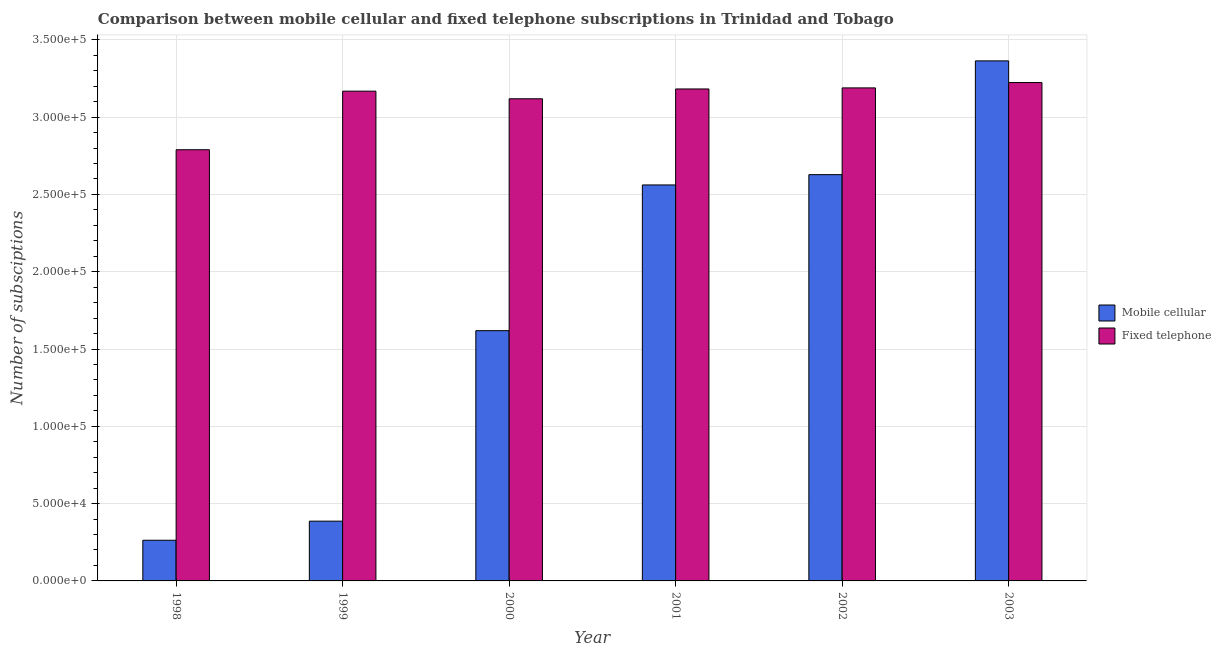How many different coloured bars are there?
Provide a short and direct response. 2. Are the number of bars per tick equal to the number of legend labels?
Offer a terse response. Yes. Are the number of bars on each tick of the X-axis equal?
Keep it short and to the point. Yes. What is the number of fixed telephone subscriptions in 2003?
Ensure brevity in your answer.  3.22e+05. Across all years, what is the maximum number of mobile cellular subscriptions?
Keep it short and to the point. 3.36e+05. Across all years, what is the minimum number of mobile cellular subscriptions?
Your answer should be very brief. 2.63e+04. What is the total number of fixed telephone subscriptions in the graph?
Your response must be concise. 1.87e+06. What is the difference between the number of mobile cellular subscriptions in 2000 and that in 2001?
Offer a terse response. -9.42e+04. What is the difference between the number of fixed telephone subscriptions in 2003 and the number of mobile cellular subscriptions in 1998?
Give a very brief answer. 4.35e+04. What is the average number of mobile cellular subscriptions per year?
Your answer should be compact. 1.80e+05. In the year 2003, what is the difference between the number of fixed telephone subscriptions and number of mobile cellular subscriptions?
Give a very brief answer. 0. What is the ratio of the number of fixed telephone subscriptions in 1999 to that in 2000?
Ensure brevity in your answer.  1.02. Is the number of mobile cellular subscriptions in 1999 less than that in 2002?
Give a very brief answer. Yes. What is the difference between the highest and the second highest number of fixed telephone subscriptions?
Keep it short and to the point. 3459. What is the difference between the highest and the lowest number of fixed telephone subscriptions?
Make the answer very short. 4.35e+04. In how many years, is the number of fixed telephone subscriptions greater than the average number of fixed telephone subscriptions taken over all years?
Provide a short and direct response. 5. What does the 2nd bar from the left in 1998 represents?
Keep it short and to the point. Fixed telephone. What does the 1st bar from the right in 1999 represents?
Provide a short and direct response. Fixed telephone. How many bars are there?
Your answer should be compact. 12. What is the difference between two consecutive major ticks on the Y-axis?
Your answer should be compact. 5.00e+04. Are the values on the major ticks of Y-axis written in scientific E-notation?
Provide a succinct answer. Yes. How many legend labels are there?
Keep it short and to the point. 2. How are the legend labels stacked?
Your answer should be compact. Vertical. What is the title of the graph?
Provide a succinct answer. Comparison between mobile cellular and fixed telephone subscriptions in Trinidad and Tobago. Does "Number of arrivals" appear as one of the legend labels in the graph?
Your answer should be compact. No. What is the label or title of the X-axis?
Offer a terse response. Year. What is the label or title of the Y-axis?
Your answer should be compact. Number of subsciptions. What is the Number of subsciptions of Mobile cellular in 1998?
Make the answer very short. 2.63e+04. What is the Number of subsciptions in Fixed telephone in 1998?
Offer a very short reply. 2.79e+05. What is the Number of subsciptions of Mobile cellular in 1999?
Your answer should be very brief. 3.87e+04. What is the Number of subsciptions in Fixed telephone in 1999?
Your answer should be compact. 3.17e+05. What is the Number of subsciptions in Mobile cellular in 2000?
Offer a terse response. 1.62e+05. What is the Number of subsciptions in Fixed telephone in 2000?
Keep it short and to the point. 3.12e+05. What is the Number of subsciptions in Mobile cellular in 2001?
Keep it short and to the point. 2.56e+05. What is the Number of subsciptions in Fixed telephone in 2001?
Provide a succinct answer. 3.18e+05. What is the Number of subsciptions in Mobile cellular in 2002?
Ensure brevity in your answer.  2.63e+05. What is the Number of subsciptions of Fixed telephone in 2002?
Give a very brief answer. 3.19e+05. What is the Number of subsciptions of Mobile cellular in 2003?
Your response must be concise. 3.36e+05. What is the Number of subsciptions of Fixed telephone in 2003?
Ensure brevity in your answer.  3.22e+05. Across all years, what is the maximum Number of subsciptions in Mobile cellular?
Make the answer very short. 3.36e+05. Across all years, what is the maximum Number of subsciptions of Fixed telephone?
Provide a short and direct response. 3.22e+05. Across all years, what is the minimum Number of subsciptions of Mobile cellular?
Your answer should be compact. 2.63e+04. Across all years, what is the minimum Number of subsciptions of Fixed telephone?
Provide a short and direct response. 2.79e+05. What is the total Number of subsciptions in Mobile cellular in the graph?
Give a very brief answer. 1.08e+06. What is the total Number of subsciptions of Fixed telephone in the graph?
Provide a short and direct response. 1.87e+06. What is the difference between the Number of subsciptions of Mobile cellular in 1998 and that in 1999?
Make the answer very short. -1.24e+04. What is the difference between the Number of subsciptions of Fixed telephone in 1998 and that in 1999?
Your response must be concise. -3.79e+04. What is the difference between the Number of subsciptions in Mobile cellular in 1998 and that in 2000?
Your answer should be very brief. -1.36e+05. What is the difference between the Number of subsciptions of Fixed telephone in 1998 and that in 2000?
Keep it short and to the point. -3.30e+04. What is the difference between the Number of subsciptions of Mobile cellular in 1998 and that in 2001?
Offer a very short reply. -2.30e+05. What is the difference between the Number of subsciptions of Fixed telephone in 1998 and that in 2001?
Offer a terse response. -3.93e+04. What is the difference between the Number of subsciptions in Mobile cellular in 1998 and that in 2002?
Offer a very short reply. -2.36e+05. What is the difference between the Number of subsciptions of Fixed telephone in 1998 and that in 2002?
Provide a short and direct response. -4.00e+04. What is the difference between the Number of subsciptions in Mobile cellular in 1998 and that in 2003?
Ensure brevity in your answer.  -3.10e+05. What is the difference between the Number of subsciptions in Fixed telephone in 1998 and that in 2003?
Ensure brevity in your answer.  -4.35e+04. What is the difference between the Number of subsciptions in Mobile cellular in 1999 and that in 2000?
Give a very brief answer. -1.23e+05. What is the difference between the Number of subsciptions in Fixed telephone in 1999 and that in 2000?
Ensure brevity in your answer.  4925. What is the difference between the Number of subsciptions in Mobile cellular in 1999 and that in 2001?
Give a very brief answer. -2.17e+05. What is the difference between the Number of subsciptions of Fixed telephone in 1999 and that in 2001?
Your answer should be compact. -1422. What is the difference between the Number of subsciptions in Mobile cellular in 1999 and that in 2002?
Ensure brevity in your answer.  -2.24e+05. What is the difference between the Number of subsciptions of Fixed telephone in 1999 and that in 2002?
Provide a succinct answer. -2112. What is the difference between the Number of subsciptions in Mobile cellular in 1999 and that in 2003?
Your answer should be compact. -2.98e+05. What is the difference between the Number of subsciptions of Fixed telephone in 1999 and that in 2003?
Give a very brief answer. -5571. What is the difference between the Number of subsciptions of Mobile cellular in 2000 and that in 2001?
Keep it short and to the point. -9.42e+04. What is the difference between the Number of subsciptions in Fixed telephone in 2000 and that in 2001?
Your answer should be very brief. -6347. What is the difference between the Number of subsciptions in Mobile cellular in 2000 and that in 2002?
Your response must be concise. -1.01e+05. What is the difference between the Number of subsciptions in Fixed telephone in 2000 and that in 2002?
Provide a succinct answer. -7037. What is the difference between the Number of subsciptions in Mobile cellular in 2000 and that in 2003?
Give a very brief answer. -1.74e+05. What is the difference between the Number of subsciptions in Fixed telephone in 2000 and that in 2003?
Make the answer very short. -1.05e+04. What is the difference between the Number of subsciptions in Mobile cellular in 2001 and that in 2002?
Ensure brevity in your answer.  -6666. What is the difference between the Number of subsciptions in Fixed telephone in 2001 and that in 2002?
Provide a succinct answer. -690. What is the difference between the Number of subsciptions in Mobile cellular in 2001 and that in 2003?
Keep it short and to the point. -8.02e+04. What is the difference between the Number of subsciptions in Fixed telephone in 2001 and that in 2003?
Your answer should be very brief. -4149. What is the difference between the Number of subsciptions of Mobile cellular in 2002 and that in 2003?
Offer a terse response. -7.36e+04. What is the difference between the Number of subsciptions of Fixed telephone in 2002 and that in 2003?
Your response must be concise. -3459. What is the difference between the Number of subsciptions in Mobile cellular in 1998 and the Number of subsciptions in Fixed telephone in 1999?
Provide a succinct answer. -2.90e+05. What is the difference between the Number of subsciptions in Mobile cellular in 1998 and the Number of subsciptions in Fixed telephone in 2000?
Your answer should be compact. -2.86e+05. What is the difference between the Number of subsciptions in Mobile cellular in 1998 and the Number of subsciptions in Fixed telephone in 2001?
Offer a very short reply. -2.92e+05. What is the difference between the Number of subsciptions in Mobile cellular in 1998 and the Number of subsciptions in Fixed telephone in 2002?
Ensure brevity in your answer.  -2.93e+05. What is the difference between the Number of subsciptions of Mobile cellular in 1998 and the Number of subsciptions of Fixed telephone in 2003?
Provide a succinct answer. -2.96e+05. What is the difference between the Number of subsciptions of Mobile cellular in 1999 and the Number of subsciptions of Fixed telephone in 2000?
Provide a succinct answer. -2.73e+05. What is the difference between the Number of subsciptions in Mobile cellular in 1999 and the Number of subsciptions in Fixed telephone in 2001?
Give a very brief answer. -2.80e+05. What is the difference between the Number of subsciptions in Mobile cellular in 1999 and the Number of subsciptions in Fixed telephone in 2002?
Keep it short and to the point. -2.80e+05. What is the difference between the Number of subsciptions of Mobile cellular in 1999 and the Number of subsciptions of Fixed telephone in 2003?
Provide a short and direct response. -2.84e+05. What is the difference between the Number of subsciptions of Mobile cellular in 2000 and the Number of subsciptions of Fixed telephone in 2001?
Your answer should be compact. -1.56e+05. What is the difference between the Number of subsciptions in Mobile cellular in 2000 and the Number of subsciptions in Fixed telephone in 2002?
Offer a very short reply. -1.57e+05. What is the difference between the Number of subsciptions of Mobile cellular in 2000 and the Number of subsciptions of Fixed telephone in 2003?
Your response must be concise. -1.60e+05. What is the difference between the Number of subsciptions of Mobile cellular in 2001 and the Number of subsciptions of Fixed telephone in 2002?
Provide a short and direct response. -6.28e+04. What is the difference between the Number of subsciptions in Mobile cellular in 2001 and the Number of subsciptions in Fixed telephone in 2003?
Provide a short and direct response. -6.62e+04. What is the difference between the Number of subsciptions in Mobile cellular in 2002 and the Number of subsciptions in Fixed telephone in 2003?
Ensure brevity in your answer.  -5.96e+04. What is the average Number of subsciptions of Mobile cellular per year?
Offer a terse response. 1.80e+05. What is the average Number of subsciptions of Fixed telephone per year?
Keep it short and to the point. 3.11e+05. In the year 1998, what is the difference between the Number of subsciptions in Mobile cellular and Number of subsciptions in Fixed telephone?
Your answer should be compact. -2.53e+05. In the year 1999, what is the difference between the Number of subsciptions of Mobile cellular and Number of subsciptions of Fixed telephone?
Your answer should be very brief. -2.78e+05. In the year 2000, what is the difference between the Number of subsciptions of Mobile cellular and Number of subsciptions of Fixed telephone?
Your response must be concise. -1.50e+05. In the year 2001, what is the difference between the Number of subsciptions in Mobile cellular and Number of subsciptions in Fixed telephone?
Offer a terse response. -6.21e+04. In the year 2002, what is the difference between the Number of subsciptions in Mobile cellular and Number of subsciptions in Fixed telephone?
Your answer should be compact. -5.61e+04. In the year 2003, what is the difference between the Number of subsciptions of Mobile cellular and Number of subsciptions of Fixed telephone?
Ensure brevity in your answer.  1.40e+04. What is the ratio of the Number of subsciptions in Mobile cellular in 1998 to that in 1999?
Provide a succinct answer. 0.68. What is the ratio of the Number of subsciptions of Fixed telephone in 1998 to that in 1999?
Offer a terse response. 0.88. What is the ratio of the Number of subsciptions of Mobile cellular in 1998 to that in 2000?
Your response must be concise. 0.16. What is the ratio of the Number of subsciptions of Fixed telephone in 1998 to that in 2000?
Ensure brevity in your answer.  0.89. What is the ratio of the Number of subsciptions in Mobile cellular in 1998 to that in 2001?
Offer a very short reply. 0.1. What is the ratio of the Number of subsciptions of Fixed telephone in 1998 to that in 2001?
Provide a short and direct response. 0.88. What is the ratio of the Number of subsciptions in Mobile cellular in 1998 to that in 2002?
Give a very brief answer. 0.1. What is the ratio of the Number of subsciptions of Fixed telephone in 1998 to that in 2002?
Offer a very short reply. 0.87. What is the ratio of the Number of subsciptions in Mobile cellular in 1998 to that in 2003?
Keep it short and to the point. 0.08. What is the ratio of the Number of subsciptions of Fixed telephone in 1998 to that in 2003?
Your response must be concise. 0.87. What is the ratio of the Number of subsciptions of Mobile cellular in 1999 to that in 2000?
Your response must be concise. 0.24. What is the ratio of the Number of subsciptions of Fixed telephone in 1999 to that in 2000?
Provide a succinct answer. 1.02. What is the ratio of the Number of subsciptions of Mobile cellular in 1999 to that in 2001?
Keep it short and to the point. 0.15. What is the ratio of the Number of subsciptions of Fixed telephone in 1999 to that in 2001?
Provide a short and direct response. 1. What is the ratio of the Number of subsciptions in Mobile cellular in 1999 to that in 2002?
Your answer should be very brief. 0.15. What is the ratio of the Number of subsciptions of Mobile cellular in 1999 to that in 2003?
Ensure brevity in your answer.  0.11. What is the ratio of the Number of subsciptions of Fixed telephone in 1999 to that in 2003?
Offer a terse response. 0.98. What is the ratio of the Number of subsciptions in Mobile cellular in 2000 to that in 2001?
Your answer should be very brief. 0.63. What is the ratio of the Number of subsciptions in Fixed telephone in 2000 to that in 2001?
Provide a succinct answer. 0.98. What is the ratio of the Number of subsciptions in Mobile cellular in 2000 to that in 2002?
Your response must be concise. 0.62. What is the ratio of the Number of subsciptions of Fixed telephone in 2000 to that in 2002?
Keep it short and to the point. 0.98. What is the ratio of the Number of subsciptions of Mobile cellular in 2000 to that in 2003?
Offer a very short reply. 0.48. What is the ratio of the Number of subsciptions of Fixed telephone in 2000 to that in 2003?
Make the answer very short. 0.97. What is the ratio of the Number of subsciptions in Mobile cellular in 2001 to that in 2002?
Provide a short and direct response. 0.97. What is the ratio of the Number of subsciptions in Fixed telephone in 2001 to that in 2002?
Your answer should be compact. 1. What is the ratio of the Number of subsciptions in Mobile cellular in 2001 to that in 2003?
Ensure brevity in your answer.  0.76. What is the ratio of the Number of subsciptions in Fixed telephone in 2001 to that in 2003?
Keep it short and to the point. 0.99. What is the ratio of the Number of subsciptions of Mobile cellular in 2002 to that in 2003?
Provide a succinct answer. 0.78. What is the ratio of the Number of subsciptions in Fixed telephone in 2002 to that in 2003?
Offer a terse response. 0.99. What is the difference between the highest and the second highest Number of subsciptions of Mobile cellular?
Offer a very short reply. 7.36e+04. What is the difference between the highest and the second highest Number of subsciptions of Fixed telephone?
Ensure brevity in your answer.  3459. What is the difference between the highest and the lowest Number of subsciptions in Mobile cellular?
Make the answer very short. 3.10e+05. What is the difference between the highest and the lowest Number of subsciptions of Fixed telephone?
Provide a succinct answer. 4.35e+04. 